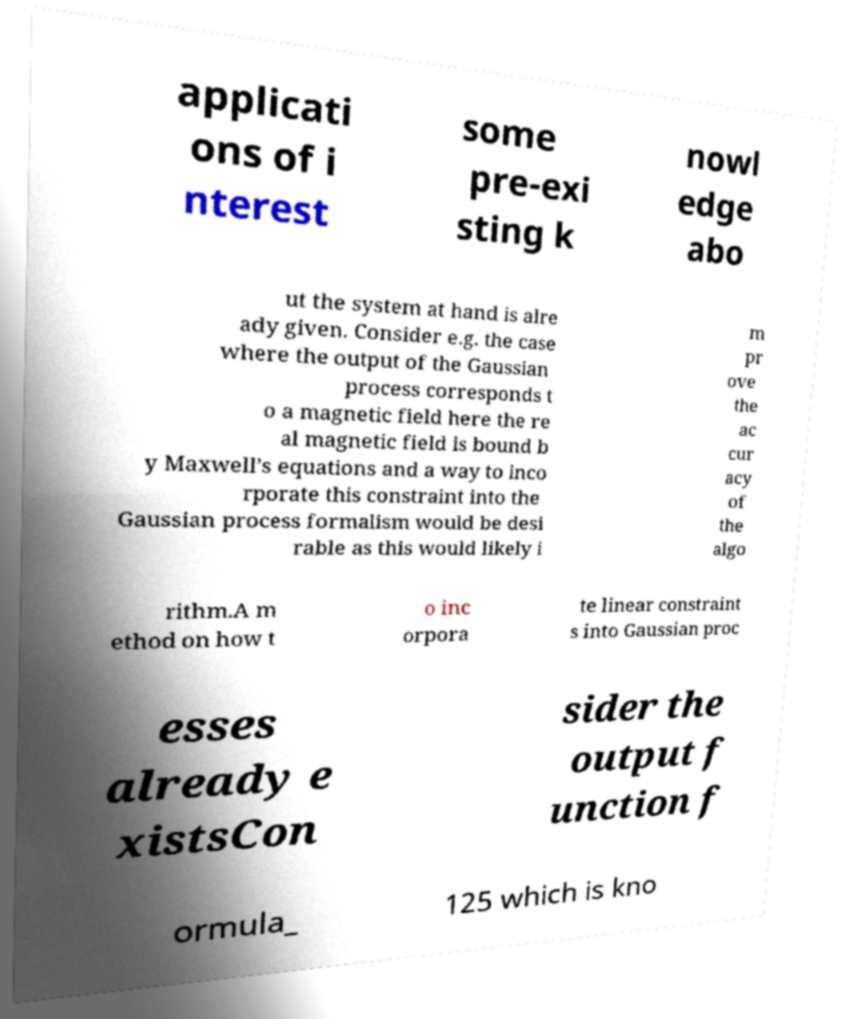There's text embedded in this image that I need extracted. Can you transcribe it verbatim? applicati ons of i nterest some pre-exi sting k nowl edge abo ut the system at hand is alre ady given. Consider e.g. the case where the output of the Gaussian process corresponds t o a magnetic field here the re al magnetic field is bound b y Maxwell’s equations and a way to inco rporate this constraint into the Gaussian process formalism would be desi rable as this would likely i m pr ove the ac cur acy of the algo rithm.A m ethod on how t o inc orpora te linear constraint s into Gaussian proc esses already e xistsCon sider the output f unction f ormula_ 125 which is kno 